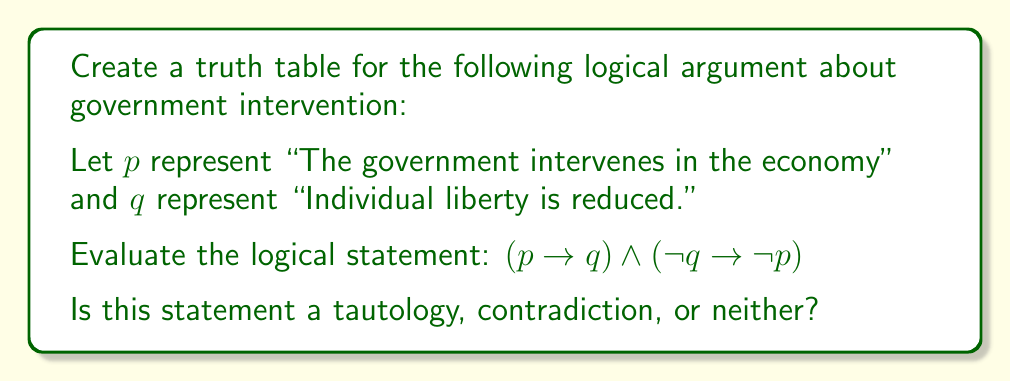Teach me how to tackle this problem. To solve this problem, we need to create a truth table for the given logical statement and analyze the results. Let's break it down step-by-step:

1) First, let's identify the components of our statement:
   - $p \rightarrow q$
   - $\neg q \rightarrow \neg p$
   - The conjunction ($\land$) of these two implications

2) We'll create a truth table with columns for $p$, $q$, $p \rightarrow q$, $\neg q \rightarrow \neg p$, and the final conjunction.

3) Truth table:

   $$
   \begin{array}{|c|c|c|c|c|}
   \hline
   p & q & p \rightarrow q & \neg q \rightarrow \neg p & (p \rightarrow q) \land (\neg q \rightarrow \neg p) \\
   \hline
   T & T & T & T & T \\
   T & F & F & T & F \\
   F & T & T & F & F \\
   F & F & T & T & T \\
   \hline
   \end{array}
   $$

4) Explanation of each column:
   - $p \rightarrow q$ is false only when $p$ is true and $q$ is false.
   - $\neg q \rightarrow \neg p$ is equivalent to $p \rightarrow q$ (its contrapositive), so it has the same truth values.
   - The final column is the conjunction of the two previous columns.

5) Analyzing the result:
   - The final column is not all true, so it's not a tautology.
   - The final column is not all false, so it's not a contradiction.
   - Therefore, this statement is neither a tautology nor a contradiction.

This result suggests that the relationship between government intervention and individual liberty, as presented in this logical argument, is not universally true or false, but depends on the specific circumstances.
Answer: Neither a tautology nor a contradiction 